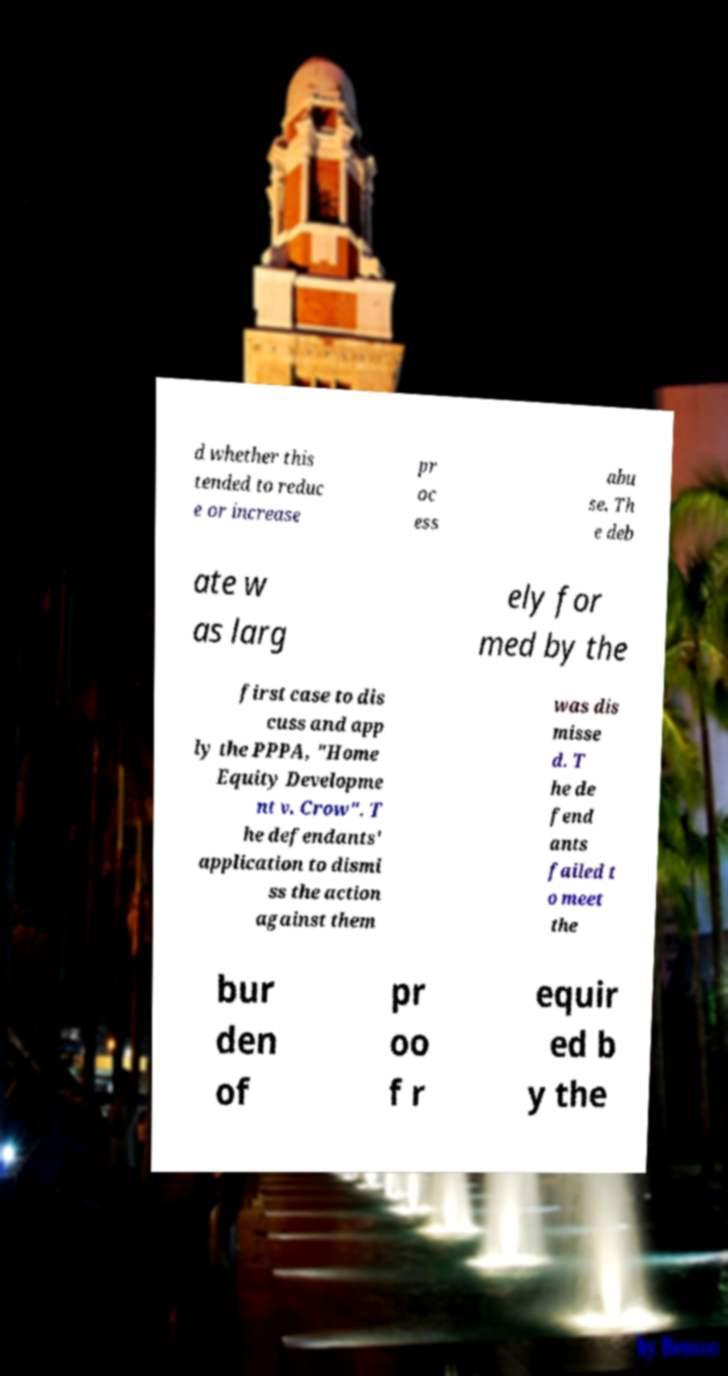Please identify and transcribe the text found in this image. d whether this tended to reduc e or increase pr oc ess abu se. Th e deb ate w as larg ely for med by the first case to dis cuss and app ly the PPPA, "Home Equity Developme nt v. Crow". T he defendants' application to dismi ss the action against them was dis misse d. T he de fend ants failed t o meet the bur den of pr oo f r equir ed b y the 